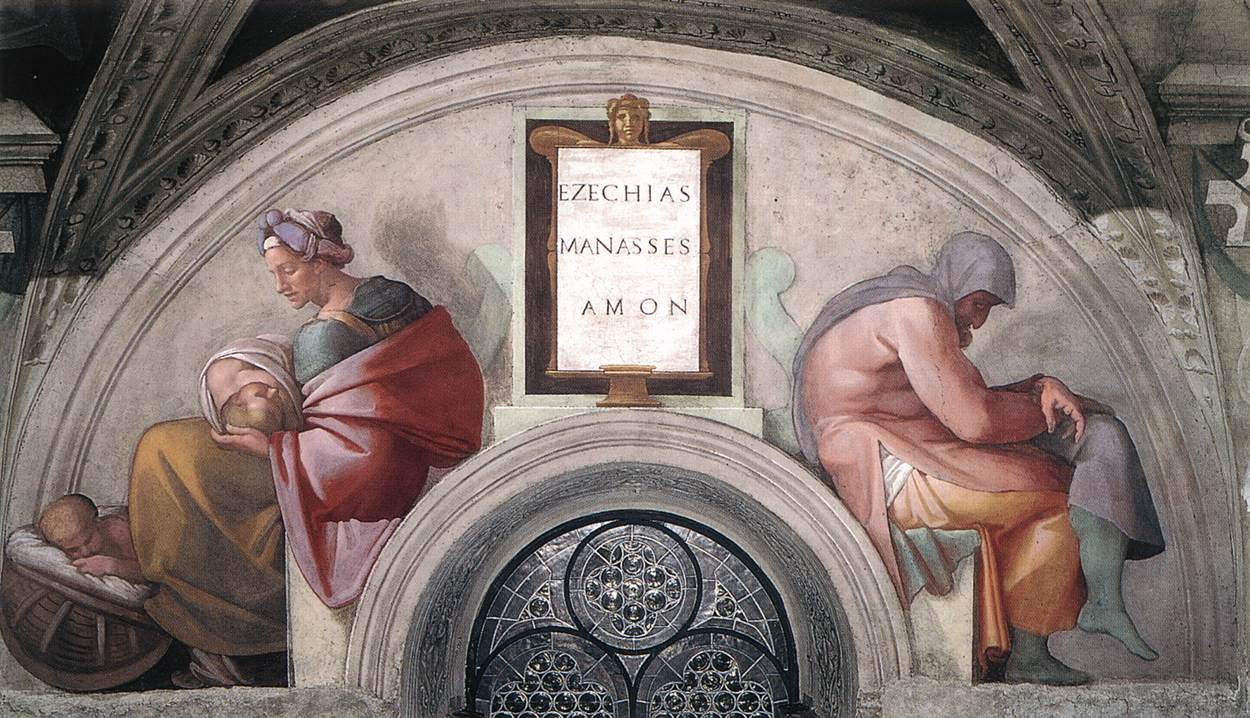Who are the figures named on the plaque and why might they be important in this context? The names on the plaque, 'Ezechias Manasses Amon', refer to Biblical kings Hezekiah, Manasseh, and Amon of Judea, known for their varying degrees of righteousness and wickedness. This could imply the fresco’s theme revolves around consequences of moral actions and legacies. Hezekiah was renowned for his reformative and righteous rule, while his son Manasseh initially led with cruelty before repenting, and Amon was noted for his wickedness. Their stories might be used here as a moral reflection on the impact of one's deeds through generations. 